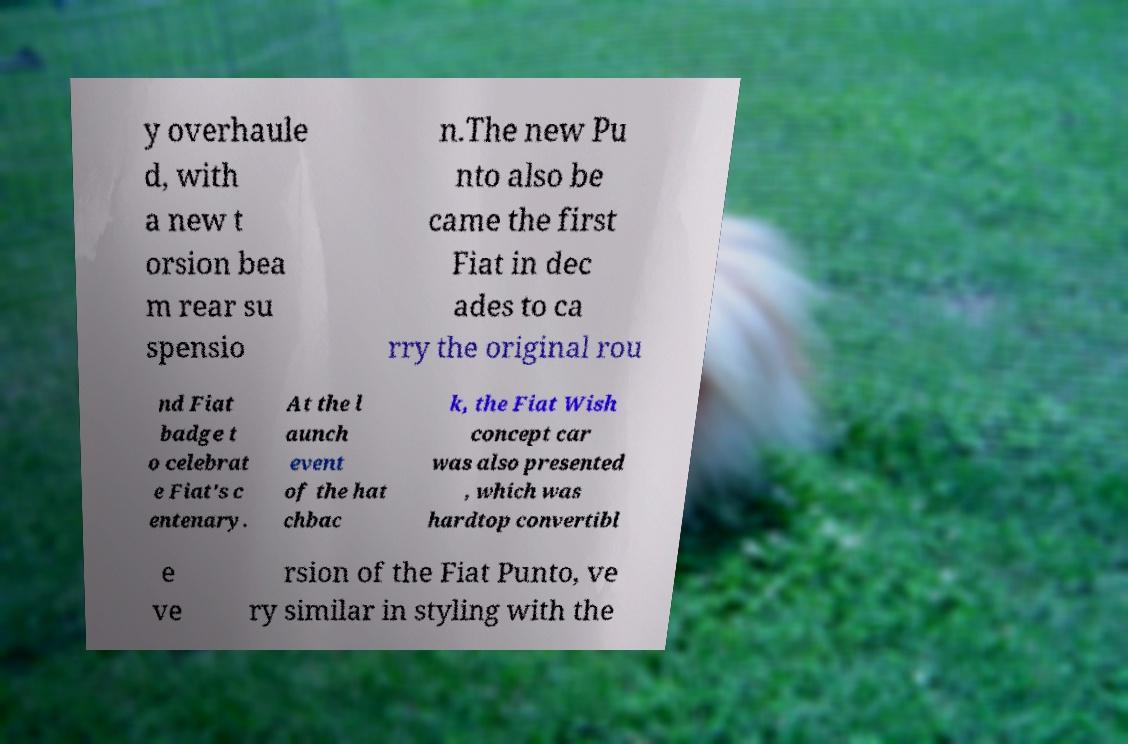There's text embedded in this image that I need extracted. Can you transcribe it verbatim? y overhaule d, with a new t orsion bea m rear su spensio n.The new Pu nto also be came the first Fiat in dec ades to ca rry the original rou nd Fiat badge t o celebrat e Fiat's c entenary. At the l aunch event of the hat chbac k, the Fiat Wish concept car was also presented , which was hardtop convertibl e ve rsion of the Fiat Punto, ve ry similar in styling with the 